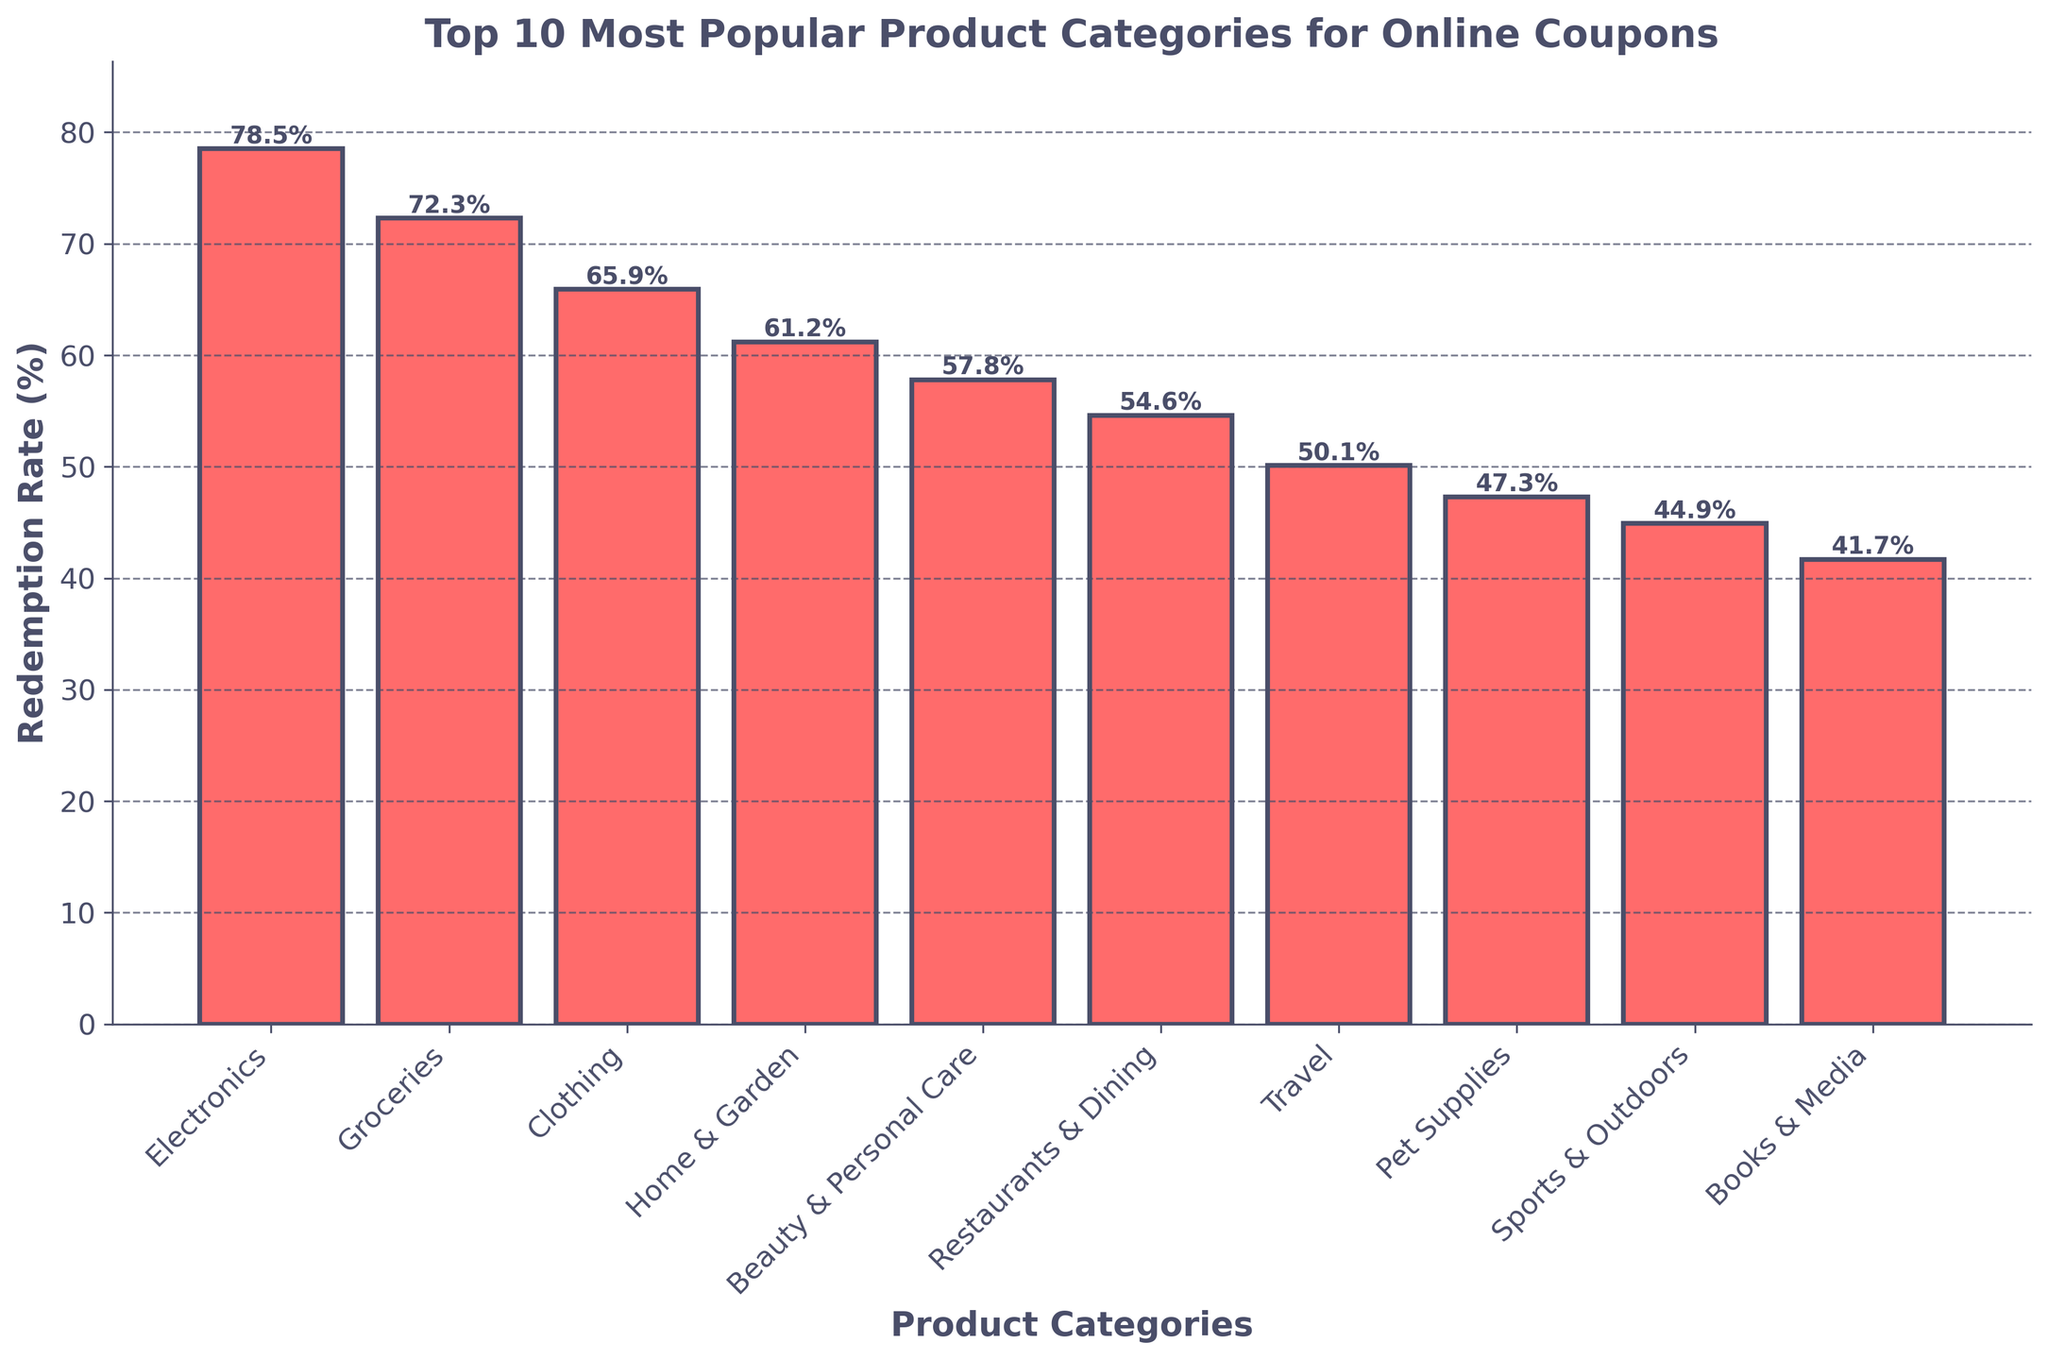Which product category has the highest redemption rate? The highest bar in the chart represents the product category with the highest redemption rate.
Answer: Electronics How much higher is the redemption rate for Electronics compared to Books & Media? Identify the redemption rates for Electronics and Books & Media from the chart (78.5% and 41.7%, respectively). Then, subtract the redemption rate of Books & Media from that of Electronics (78.5 - 41.7).
Answer: 36.8% Which product categories have a redemption rate greater than 60%? Identify all the bars with heights greater than 60%. These correspond to Electronics (78.5%), Groceries (72.3%), Clothing (65.9%), and Home & Garden (61.2%).
Answer: Electronics, Groceries, Clothing, and Home & Garden Which is more popular in terms of redemption rate: Restaurants & Dining or Beauty & Personal Care? Compare the heights of the bars for Restaurants & Dining (54.6%) and Beauty & Personal Care (57.8%). Beauty & Personal Care has a higher redemption rate.
Answer: Beauty & Personal Care What is the difference in redemption rates between the categories with the highest and lowest rates? Identify the categories with the highest and lowest redemption rates: Electronics (78.5%) and Books & Media (41.7%), respectively. Subtract the redemption rate of Books & Media from Electronics (78.5 - 41.7).
Answer: 36.8% If you average the redemption rates of Groceries, Clothing, and Travel, what is the result? Retrieve the redemption rates: Groceries (72.3%), Clothing (65.9%), and Travel (50.1%). Sum these values (72.3 + 65.9 + 50.1 = 188.3) and divide by 3 (188.3 / 3).
Answer: 62.8% Which categories have a redemption rate less than 50%? Identify the bars with heights less than 50%. These are Pet Supplies (47.3%), Sports & Outdoors (44.9%), and Books & Media (41.7%).
Answer: Pet Supplies, Sports & Outdoors, and Books & Media What is the combined redemption rate of Home & Garden and Pet Supplies? Retrieve the redemption rates for Home & Garden (61.2%) and Pet Supplies (47.3%). Sum these values (61.2 + 47.3).
Answer: 108.5% Are there more categories with redemption rates above or below the average redemption rate of all categories? First, calculate the average redemption rate by summing all rates and dividing by the number of categories (78.5 + 72.3 + 65.9 + 61.2 + 57.8 + 54.6 + 50.1 + 47.3 + 44.9 + 41.7 = 574.3; 574.3 / 10 = 57.43). Count categories above and below 57.43%. There are 5 categories above and 5 below.
Answer: It's equal (5 each above and below) What is the redemption rate difference between Groceries and the average for all categories? Calculate the average redemption rate (574.3 / 10 = 57.43%). Then subtract this from the redemption rate for Groceries (72.3 - 57.43).
Answer: 14.87% 